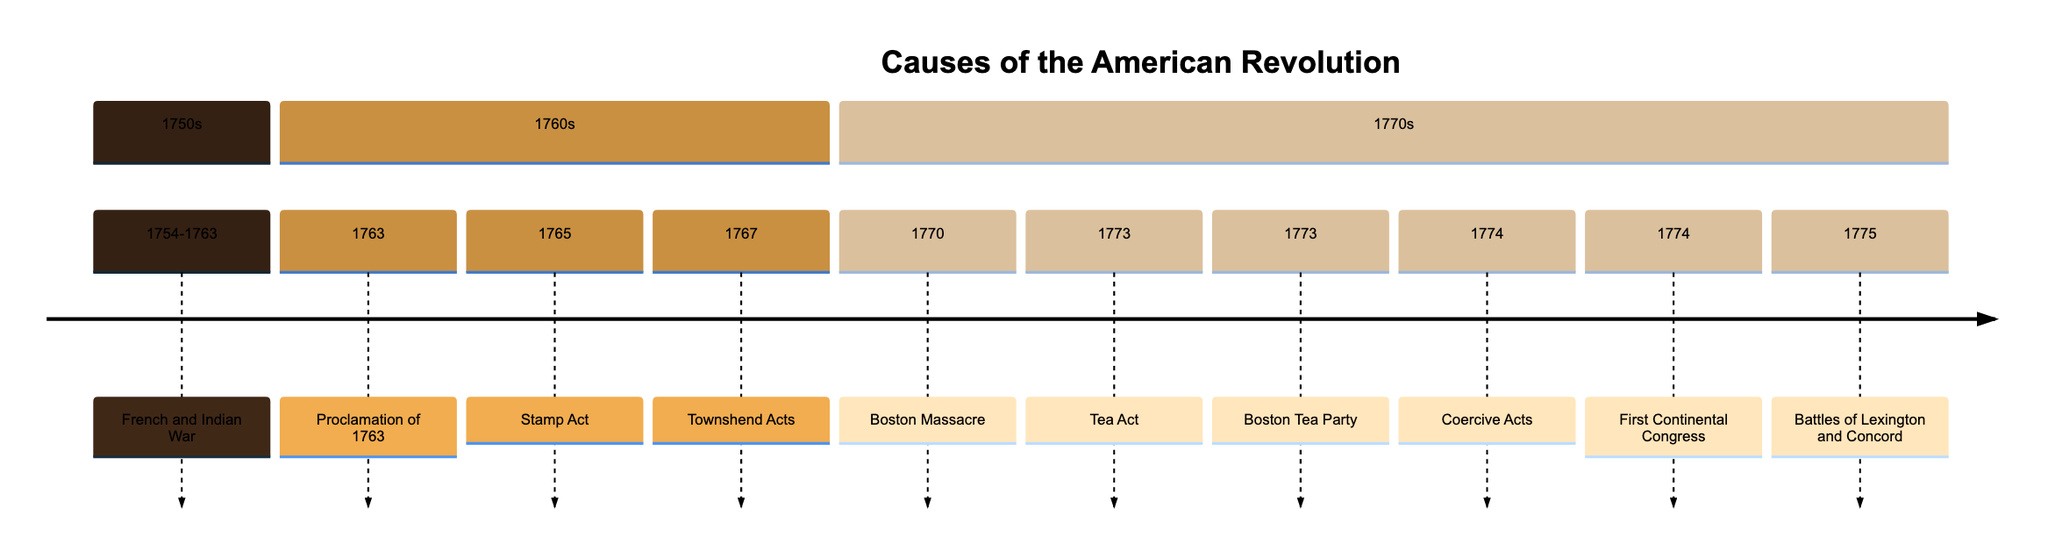What significant event occurred in the 1750s? The only event listed in the 1750s section of the timeline is the French and Indian War, which took place from 1754 to 1763.
Answer: French and Indian War How many events are listed in the 1770s section? In the 1770s section, there are five events noted: the Boston Massacre, Tea Act, Boston Tea Party, Coercive Acts, and First Continental Congress.
Answer: 5 Which event immediately followed the Stamp Act? The Stamp Act occurred in 1765, and the next event listed is the Townshend Acts in 1767. Therefore, the event that immediately followed is the Townshend Acts.
Answer: Townshend Acts What was the first event listed in the timeline? The timeline begins with the French and Indian War, which started in 1754. This is the first event represented in the diagram.
Answer: French and Indian War What two events occurred in 1774? The two events that took place in 1774, as shown in the timeline, are the Coercive Acts and the First Continental Congress.
Answer: Coercive Acts, First Continental Congress Which act directly led to the Boston Tea Party? The event that directly led to the Boston Tea Party was the Tea Act in 1773, which is noted just prior to the Boston Tea Party in the timeline.
Answer: Tea Act What can be inferred about colonial reactions based on the events listed? The events indicate a rising tension and series of reactions from colonists regarding British policies, culminating in protests like the Boston Tea Party and the formation of the First Continental Congress. This shows increasing resistance against British rule.
Answer: Increasing tension and resistance What year did the Battles of Lexington and Concord take place? The Battles of Lexington and Concord occurred in 1775, as indicated in the timeline.
Answer: 1775 